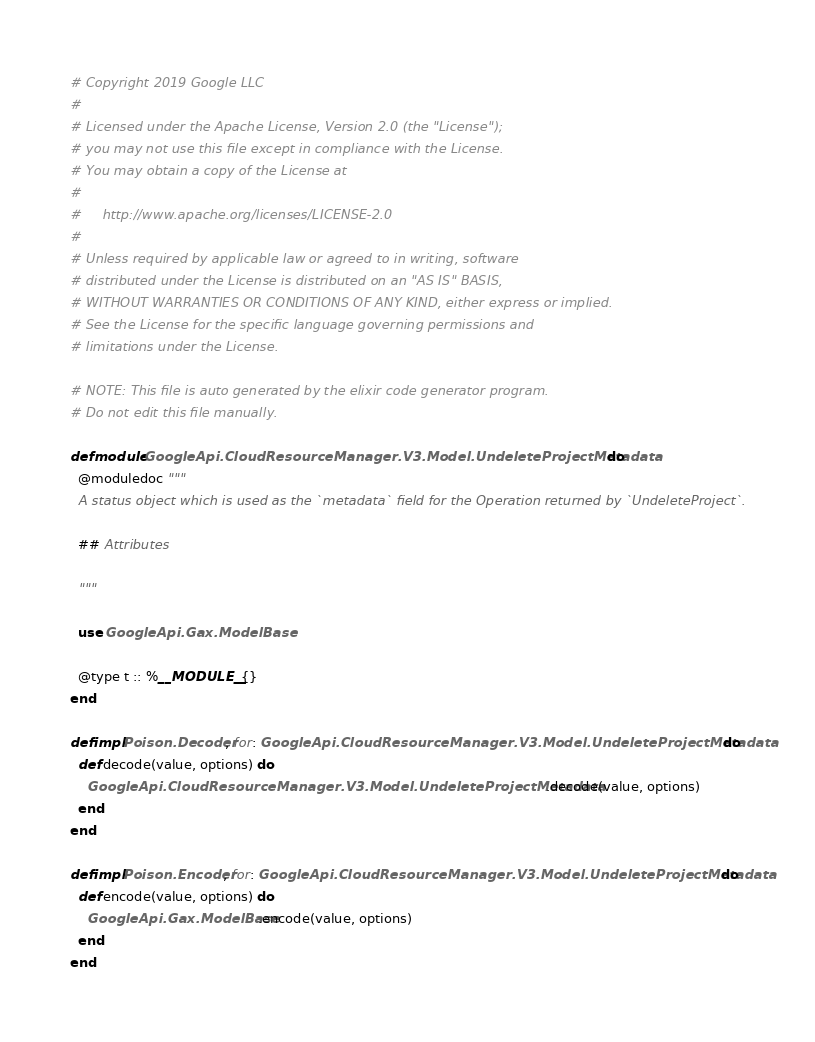<code> <loc_0><loc_0><loc_500><loc_500><_Elixir_># Copyright 2019 Google LLC
#
# Licensed under the Apache License, Version 2.0 (the "License");
# you may not use this file except in compliance with the License.
# You may obtain a copy of the License at
#
#     http://www.apache.org/licenses/LICENSE-2.0
#
# Unless required by applicable law or agreed to in writing, software
# distributed under the License is distributed on an "AS IS" BASIS,
# WITHOUT WARRANTIES OR CONDITIONS OF ANY KIND, either express or implied.
# See the License for the specific language governing permissions and
# limitations under the License.

# NOTE: This file is auto generated by the elixir code generator program.
# Do not edit this file manually.

defmodule GoogleApi.CloudResourceManager.V3.Model.UndeleteProjectMetadata do
  @moduledoc """
  A status object which is used as the `metadata` field for the Operation returned by `UndeleteProject`.

  ## Attributes

  """

  use GoogleApi.Gax.ModelBase

  @type t :: %__MODULE__{}
end

defimpl Poison.Decoder, for: GoogleApi.CloudResourceManager.V3.Model.UndeleteProjectMetadata do
  def decode(value, options) do
    GoogleApi.CloudResourceManager.V3.Model.UndeleteProjectMetadata.decode(value, options)
  end
end

defimpl Poison.Encoder, for: GoogleApi.CloudResourceManager.V3.Model.UndeleteProjectMetadata do
  def encode(value, options) do
    GoogleApi.Gax.ModelBase.encode(value, options)
  end
end
</code> 